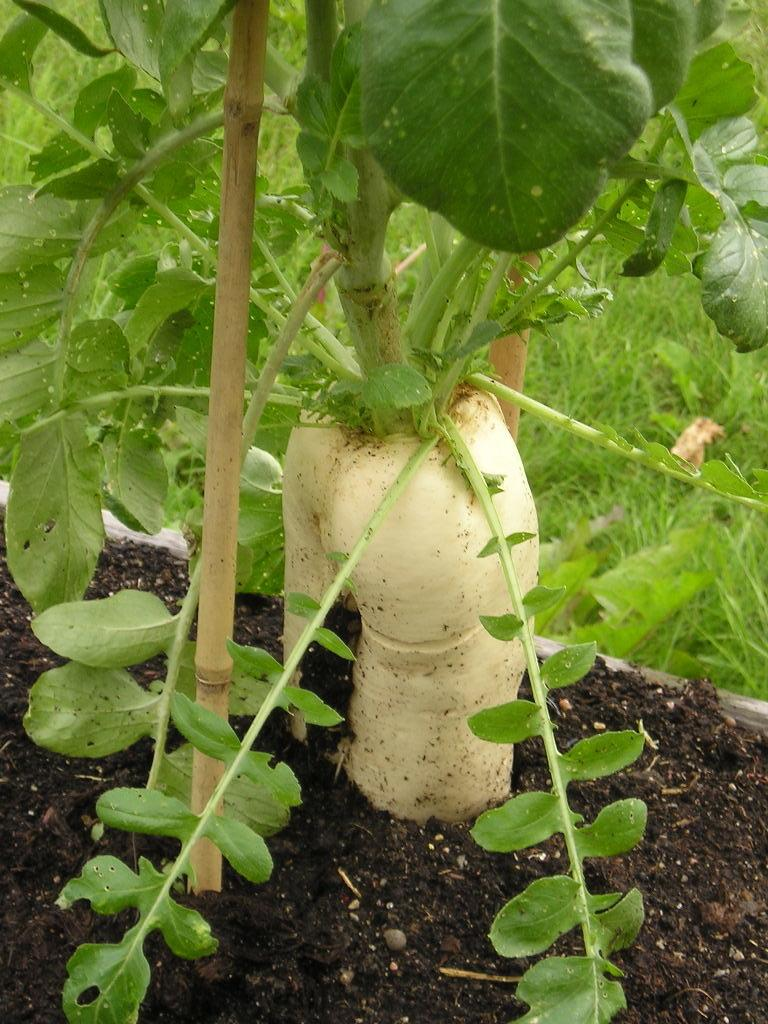What type of plant can be seen in the image? There is a vegetable plant present in the image. What object is visible in the image, besides the plant? There is a stick in the image. What is at the bottom of the image? Soil is visible at the bottom of the image. What can be seen in the background of the image? There is grass in the background of the image. Where is the mother standing in the image? There is no mother present in the image. How many ants can be seen crawling on the vegetable plant in the image? There are no ants visible in the image. 